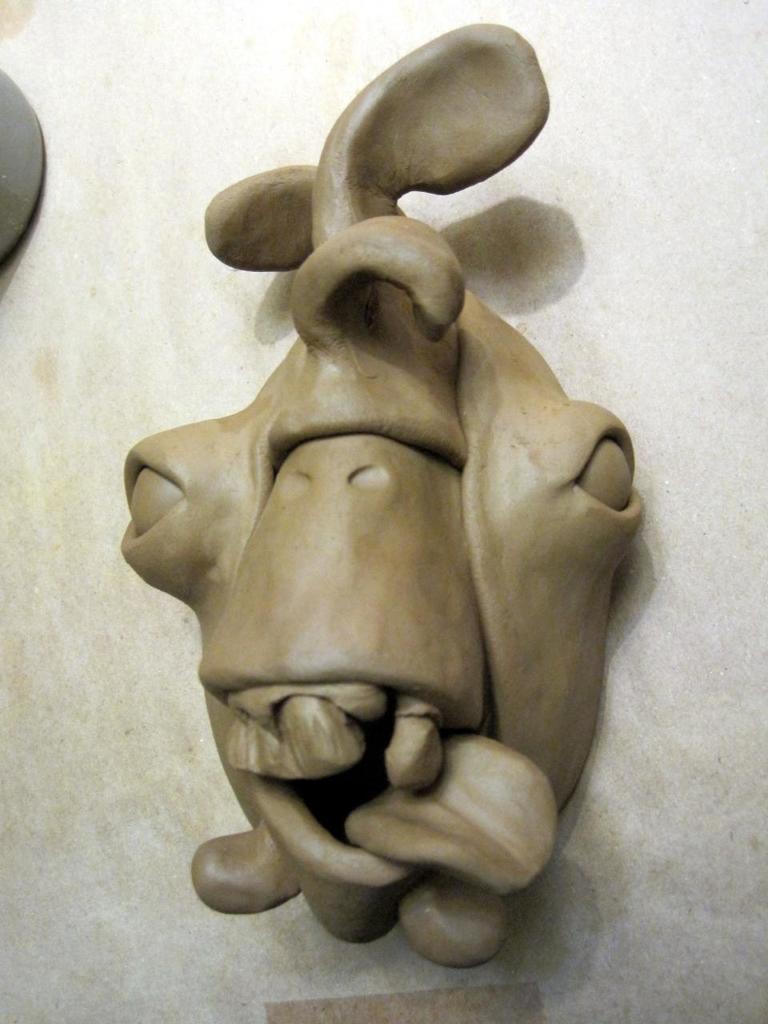Describe this image in one or two sentences. This picture looks like a clay toy. 